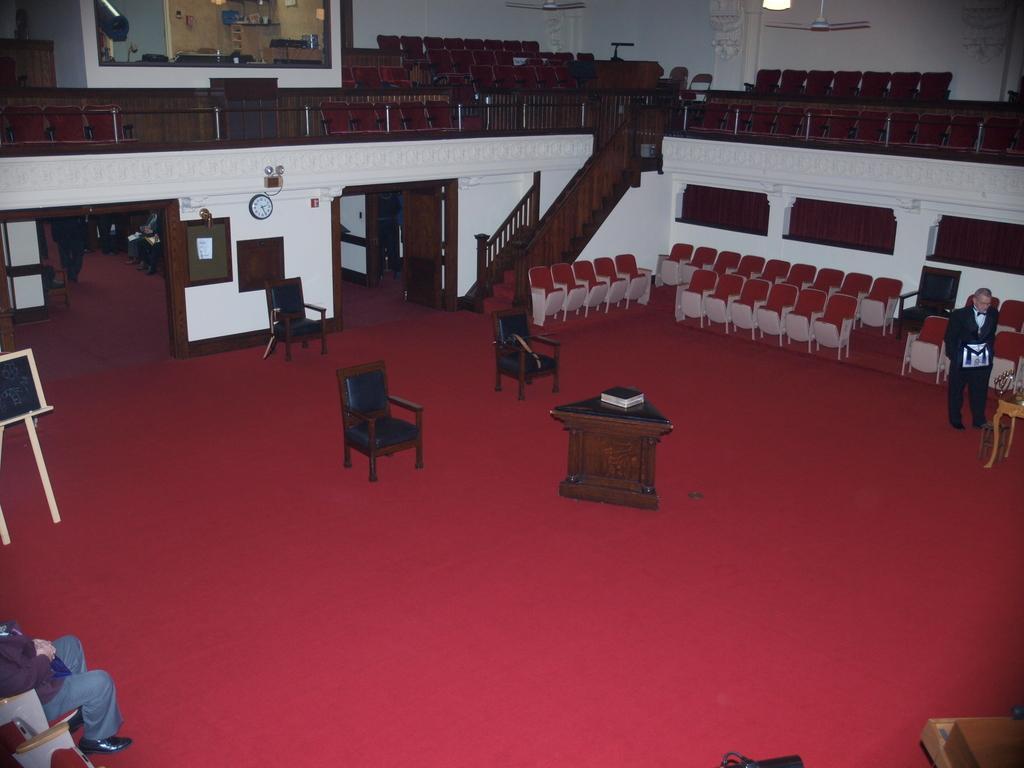Can you describe this image briefly? In this image there are a group of chairs in the center beside the chairs there is one table. On that table there is one book and on the bottom of the left corner there is one person who is sitting on a chair and in the center there is a wall and some doors are there and on that wall there is one photo frame and some boards are there and on the top there are some chairs and fans are there. On the right side there is one person who is standing and on the floor there is one red carpet. 